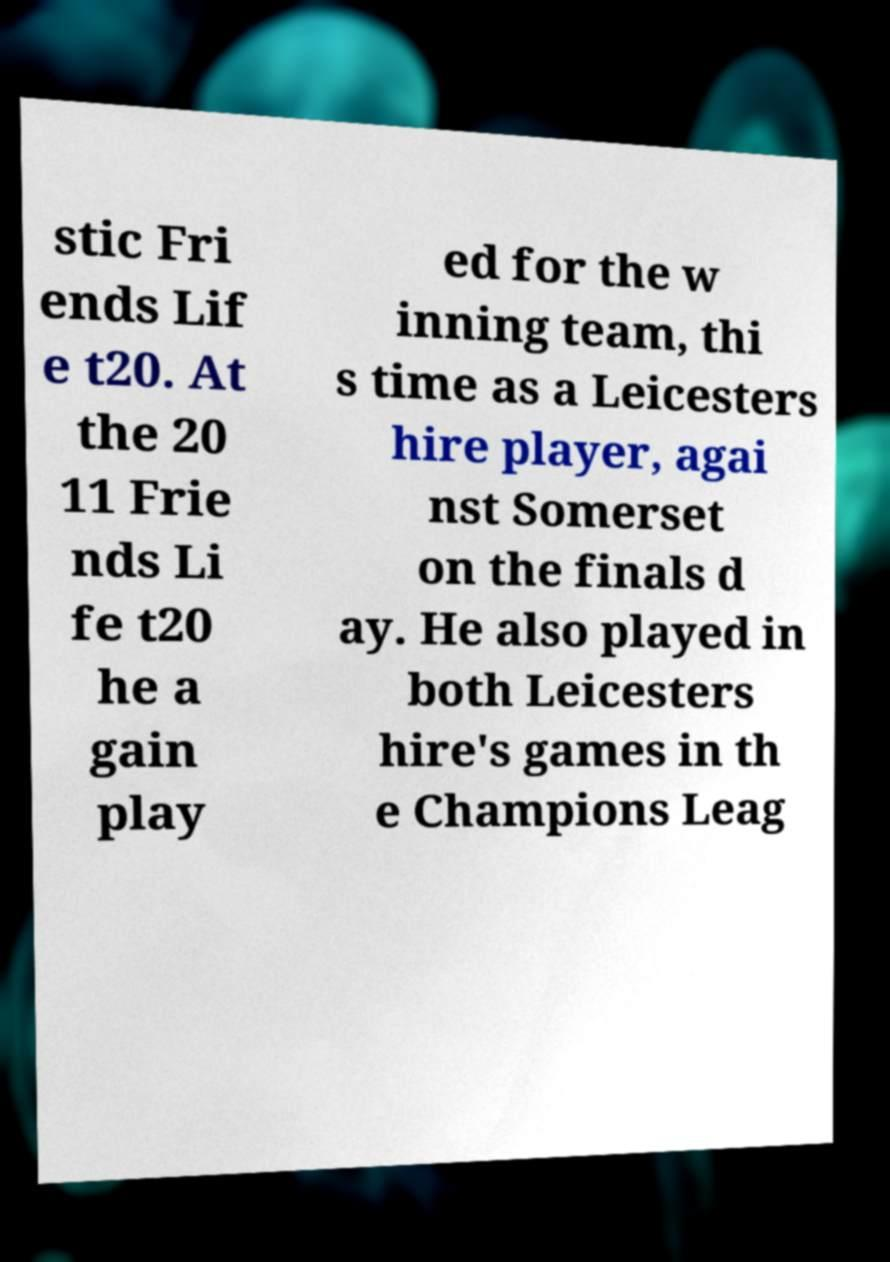I need the written content from this picture converted into text. Can you do that? stic Fri ends Lif e t20. At the 20 11 Frie nds Li fe t20 he a gain play ed for the w inning team, thi s time as a Leicesters hire player, agai nst Somerset on the finals d ay. He also played in both Leicesters hire's games in th e Champions Leag 